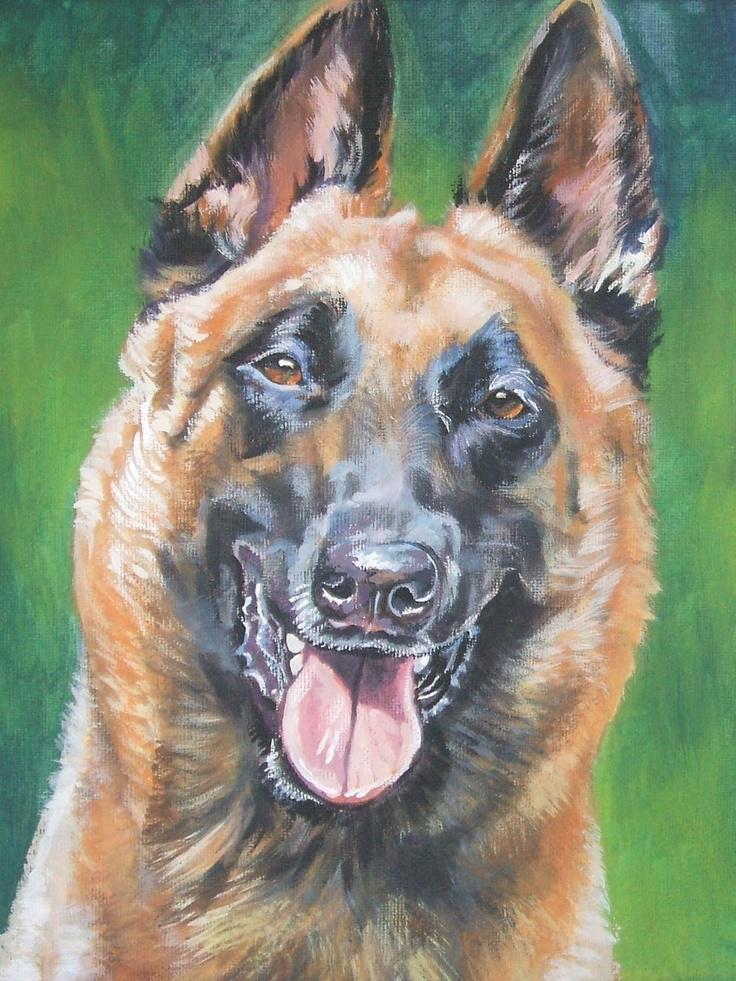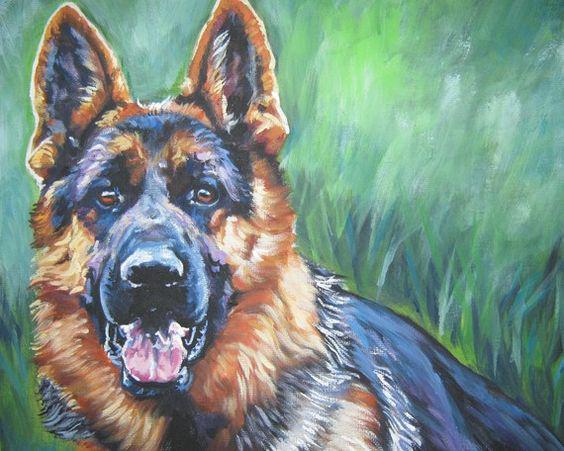The first image is the image on the left, the second image is the image on the right. Given the left and right images, does the statement "The dog on the left is lying down in the grass." hold true? Answer yes or no. No. 